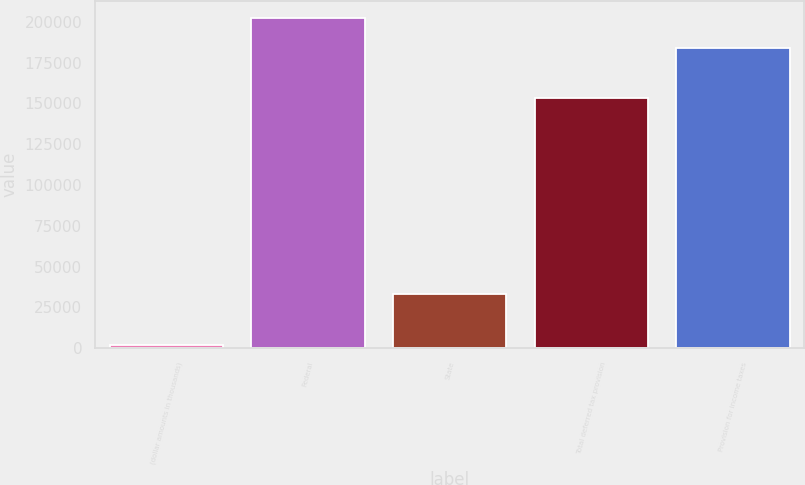Convert chart to OTSL. <chart><loc_0><loc_0><loc_500><loc_500><bar_chart><fcel>(dollar amounts in thousands)<fcel>Federal<fcel>State<fcel>Total deferred tax provision<fcel>Provision for income taxes<nl><fcel>2012<fcel>202533<fcel>33273<fcel>153123<fcel>184095<nl></chart> 